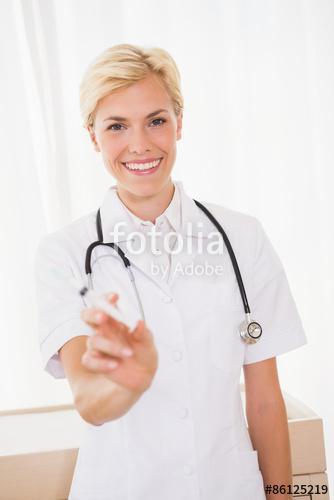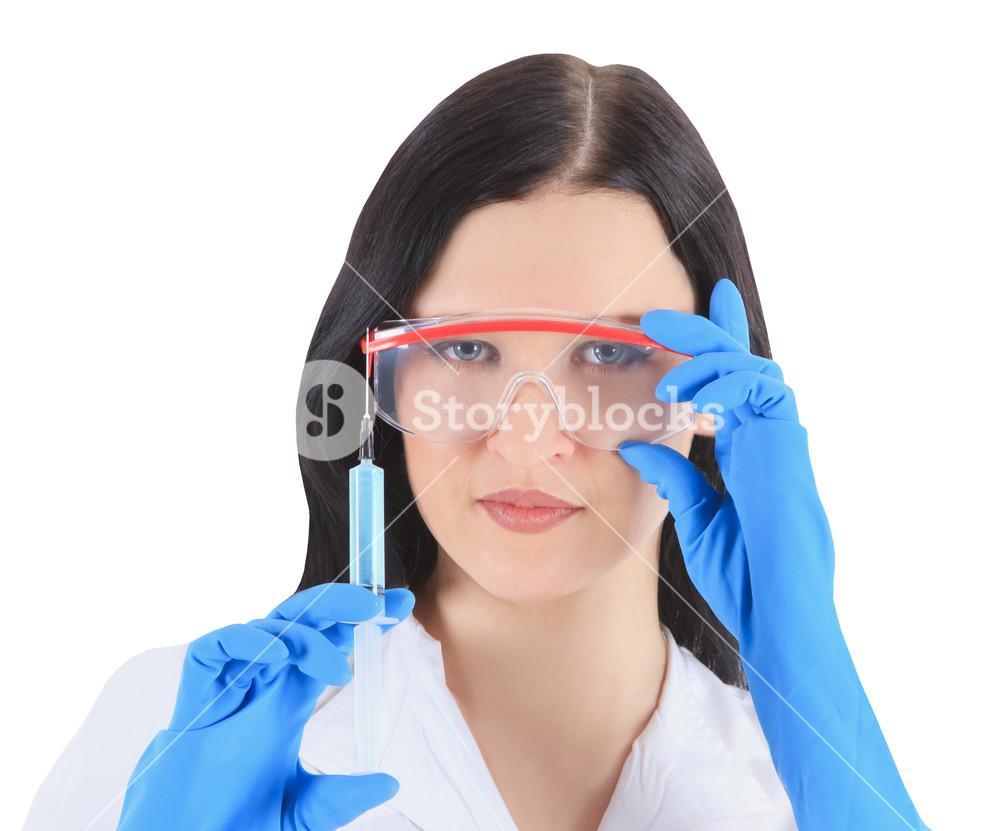The first image is the image on the left, the second image is the image on the right. Considering the images on both sides, is "The left and right image contains a total of two woman holding needles." valid? Answer yes or no. Yes. The first image is the image on the left, the second image is the image on the right. Given the left and right images, does the statement "The right image shows a forward-facing woman with a bare neck and white shirt holding up a syringe of yellow liquid." hold true? Answer yes or no. No. 